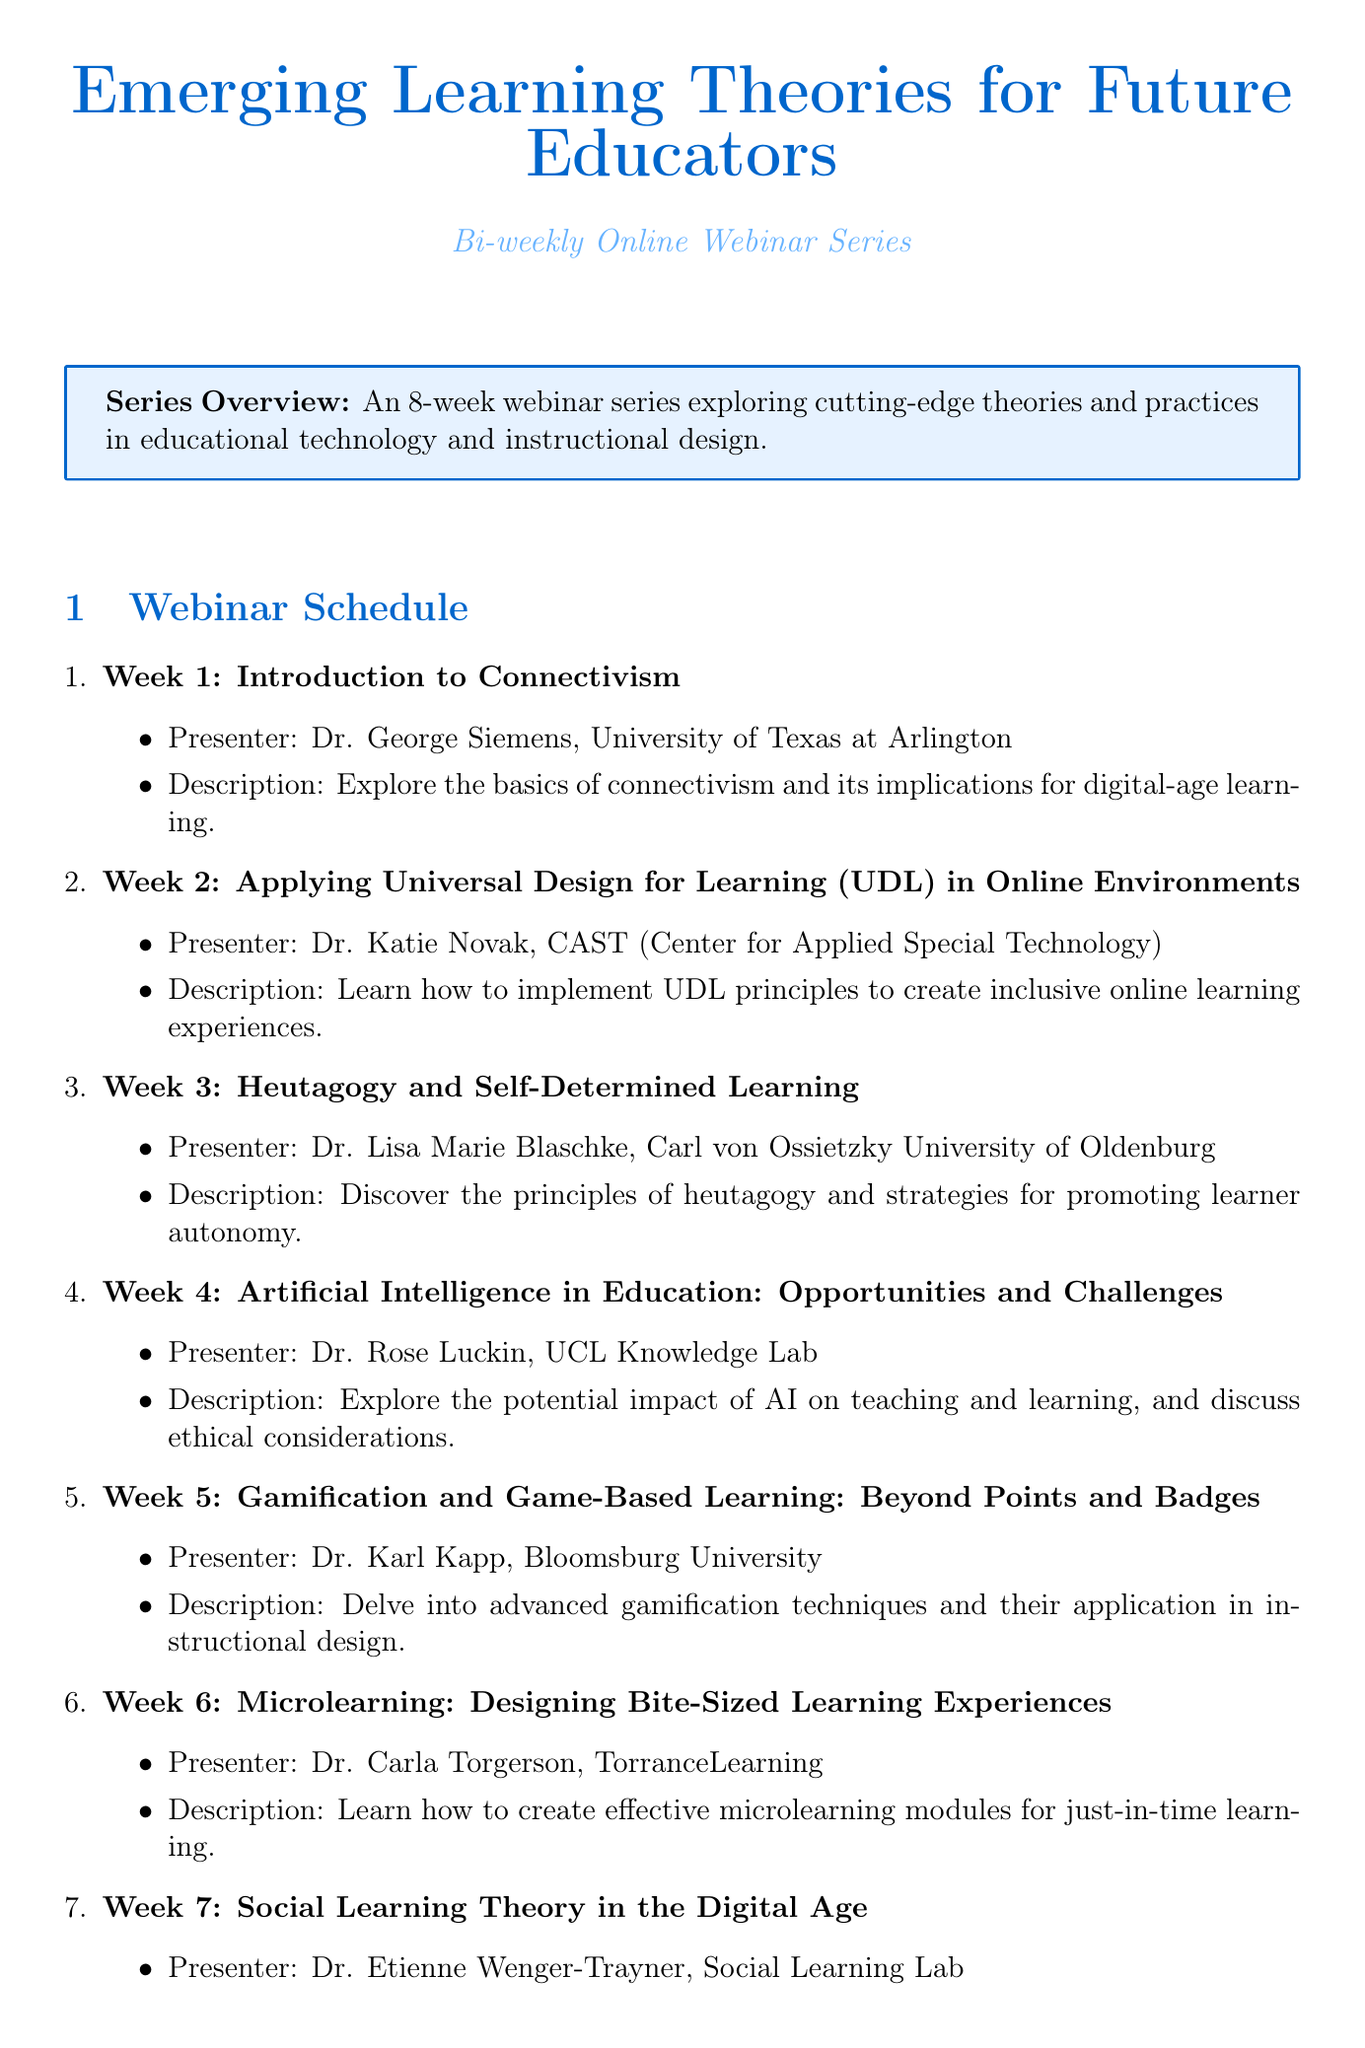What is the title of the webinar series? The title of the webinar series is stated at the beginning of the document.
Answer: Emerging Learning Theories for Future Educators Who is the presenter for Week 5? The presenter for Week 5 is listed in the schedule for that specific week.
Answer: Dr. Karl Kapp How many weeks does the webinar series last? The duration of the series is mentioned explicitly in the overview section.
Answer: 8 weeks What is the frequency of the webinars? The frequency is specified in the document as part of the schedule details.
Answer: Bi-weekly Which week focuses on Heutagogy? The week for Heutagogy is identifiable by examining the webinar titles and their corresponding weeks.
Answer: Week 3 What institution is Dr. Rose Luckin affiliated with? The institution for Dr. Rose Luckin is provided alongside her name in the Week 4 section.
Answer: UCL Knowledge Lab What is one of the additional resources listed? The additional resources section contains various types of resources including books and journals, which can be identified.
Answer: Emerging Learning Design & Technologies When is the Learning & Technology Conference scheduled? The date for the conference is clearly mentioned in the additional resources section.
Answer: October 2023 